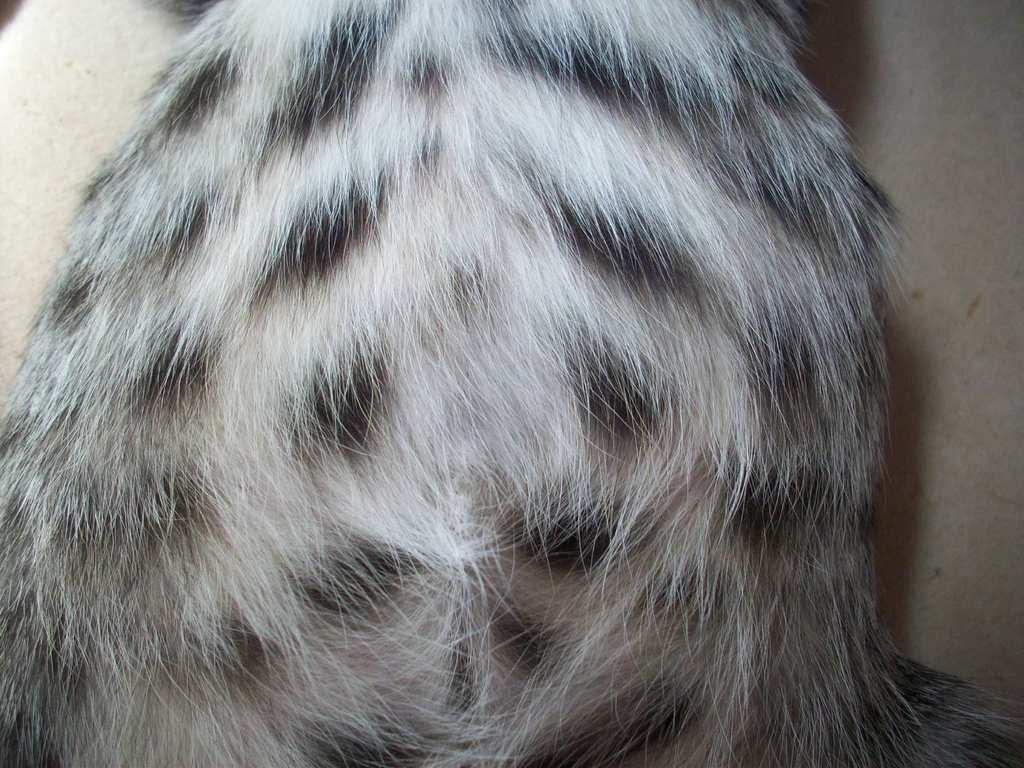What is the main subject in the foreground of the image? There is fur of an animal in the foreground of the image. Can you describe the background of the image? The background of the image is creamy. What type of string is being used by the duck in the image? There is no duck or string present in the image; it features the fur of an animal in the foreground and a creamy background. 